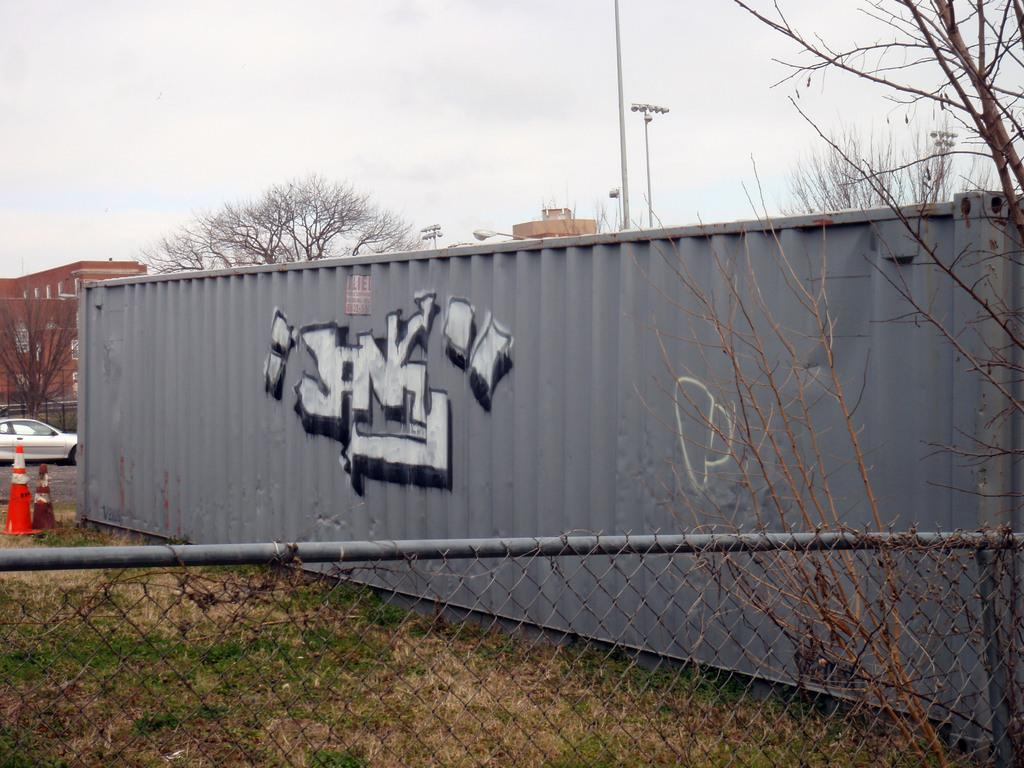<image>
Present a compact description of the photo's key features. A large grey shipping container has graffiti on it that says Jank. 